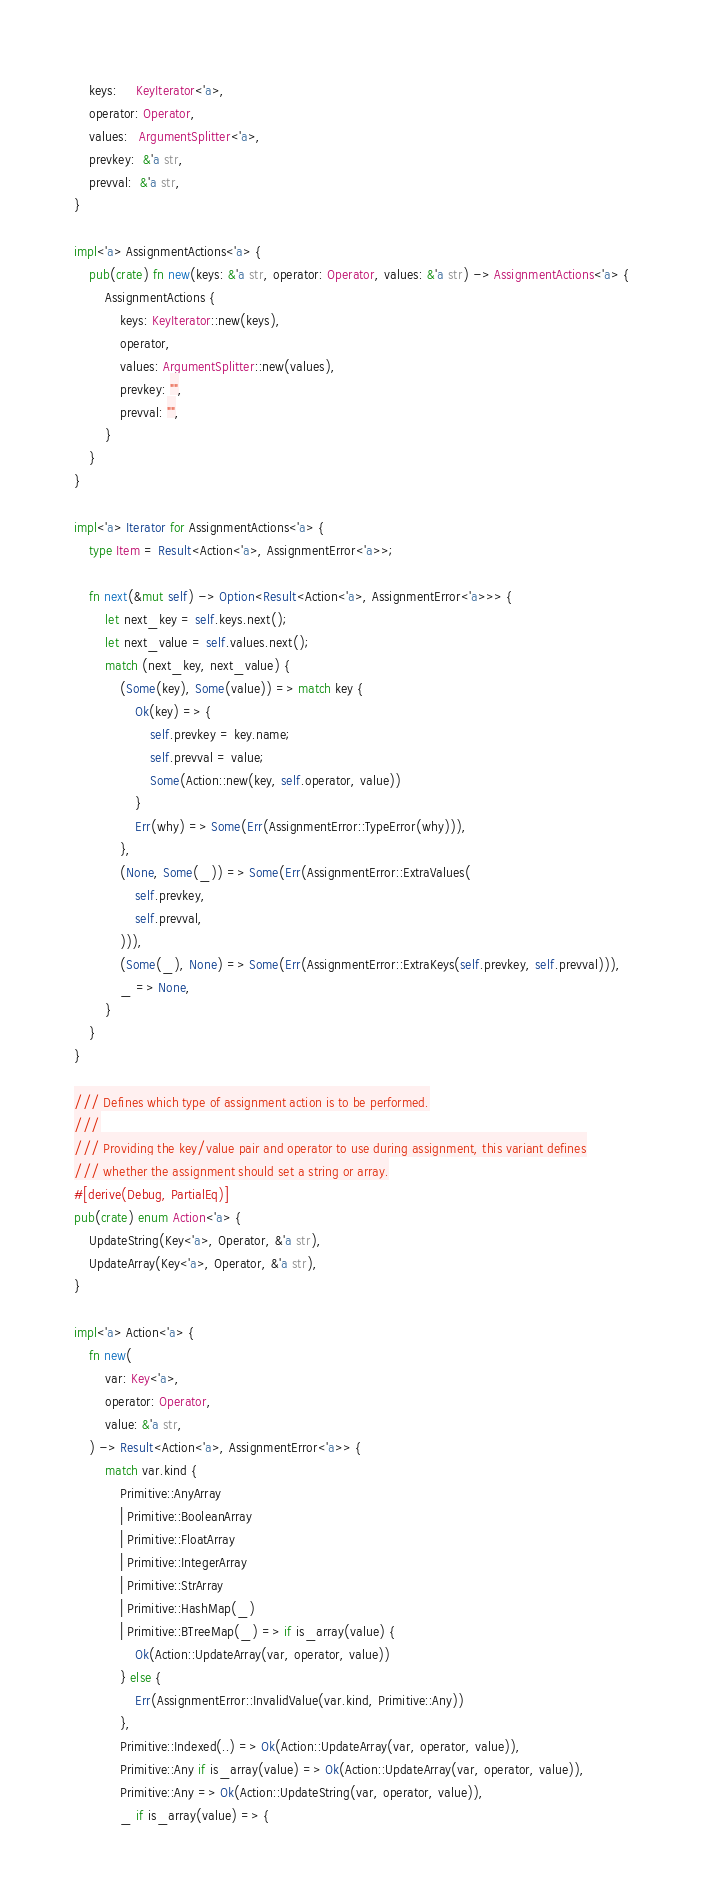Convert code to text. <code><loc_0><loc_0><loc_500><loc_500><_Rust_>    keys:     KeyIterator<'a>,
    operator: Operator,
    values:   ArgumentSplitter<'a>,
    prevkey:  &'a str,
    prevval:  &'a str,
}

impl<'a> AssignmentActions<'a> {
    pub(crate) fn new(keys: &'a str, operator: Operator, values: &'a str) -> AssignmentActions<'a> {
        AssignmentActions {
            keys: KeyIterator::new(keys),
            operator,
            values: ArgumentSplitter::new(values),
            prevkey: "",
            prevval: "",
        }
    }
}

impl<'a> Iterator for AssignmentActions<'a> {
    type Item = Result<Action<'a>, AssignmentError<'a>>;

    fn next(&mut self) -> Option<Result<Action<'a>, AssignmentError<'a>>> {
        let next_key = self.keys.next();
        let next_value = self.values.next();
        match (next_key, next_value) {
            (Some(key), Some(value)) => match key {
                Ok(key) => {
                    self.prevkey = key.name;
                    self.prevval = value;
                    Some(Action::new(key, self.operator, value))
                }
                Err(why) => Some(Err(AssignmentError::TypeError(why))),
            },
            (None, Some(_)) => Some(Err(AssignmentError::ExtraValues(
                self.prevkey,
                self.prevval,
            ))),
            (Some(_), None) => Some(Err(AssignmentError::ExtraKeys(self.prevkey, self.prevval))),
            _ => None,
        }
    }
}

/// Defines which type of assignment action is to be performed.
///
/// Providing the key/value pair and operator to use during assignment, this variant defines
/// whether the assignment should set a string or array.
#[derive(Debug, PartialEq)]
pub(crate) enum Action<'a> {
    UpdateString(Key<'a>, Operator, &'a str),
    UpdateArray(Key<'a>, Operator, &'a str),
}

impl<'a> Action<'a> {
    fn new(
        var: Key<'a>,
        operator: Operator,
        value: &'a str,
    ) -> Result<Action<'a>, AssignmentError<'a>> {
        match var.kind {
            Primitive::AnyArray
            | Primitive::BooleanArray
            | Primitive::FloatArray
            | Primitive::IntegerArray
            | Primitive::StrArray
            | Primitive::HashMap(_)
            | Primitive::BTreeMap(_) => if is_array(value) {
                Ok(Action::UpdateArray(var, operator, value))
            } else {
                Err(AssignmentError::InvalidValue(var.kind, Primitive::Any))
            },
            Primitive::Indexed(..) => Ok(Action::UpdateArray(var, operator, value)),
            Primitive::Any if is_array(value) => Ok(Action::UpdateArray(var, operator, value)),
            Primitive::Any => Ok(Action::UpdateString(var, operator, value)),
            _ if is_array(value) => {</code> 